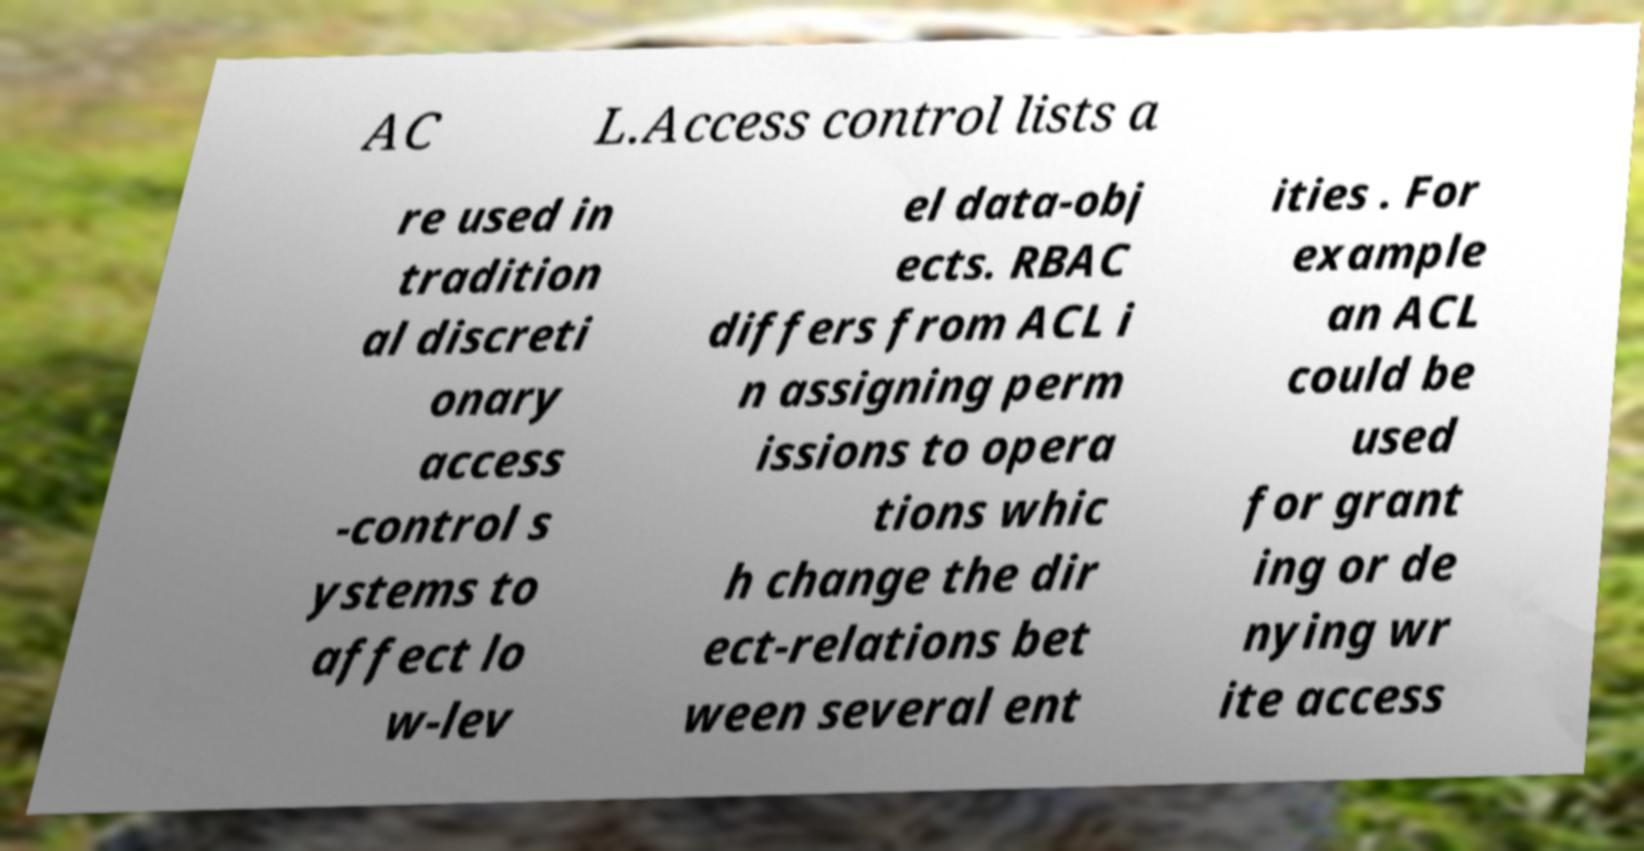Can you read and provide the text displayed in the image?This photo seems to have some interesting text. Can you extract and type it out for me? AC L.Access control lists a re used in tradition al discreti onary access -control s ystems to affect lo w-lev el data-obj ects. RBAC differs from ACL i n assigning perm issions to opera tions whic h change the dir ect-relations bet ween several ent ities . For example an ACL could be used for grant ing or de nying wr ite access 